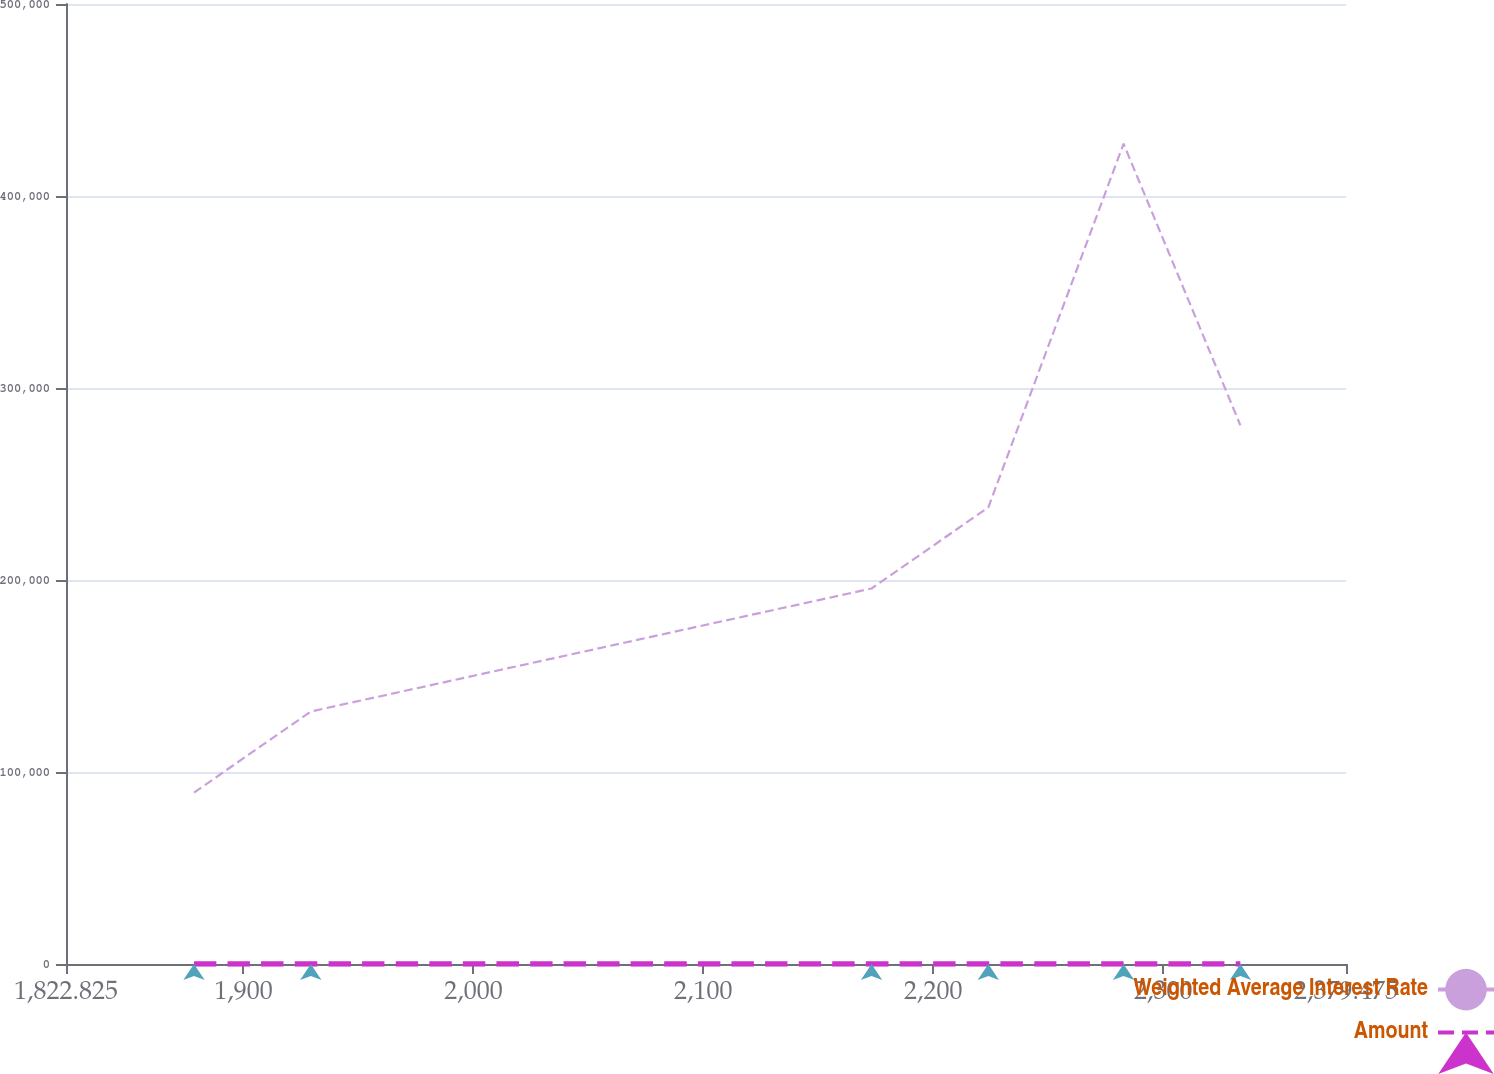Convert chart. <chart><loc_0><loc_0><loc_500><loc_500><line_chart><ecel><fcel>Weighted Average Interest Rate<fcel>Amount<nl><fcel>1878.49<fcel>89278.2<fcel>7.13<nl><fcel>1929.29<fcel>131520<fcel>4.07<nl><fcel>2173.14<fcel>195574<fcel>5.09<nl><fcel>2223.93<fcel>237816<fcel>6.08<nl><fcel>2282.75<fcel>427214<fcel>7.46<nl><fcel>2333.55<fcel>280545<fcel>5.75<nl><fcel>2384.35<fcel>47036.3<fcel>5.42<nl><fcel>2435.14<fcel>4794.34<fcel>6.41<nl></chart> 